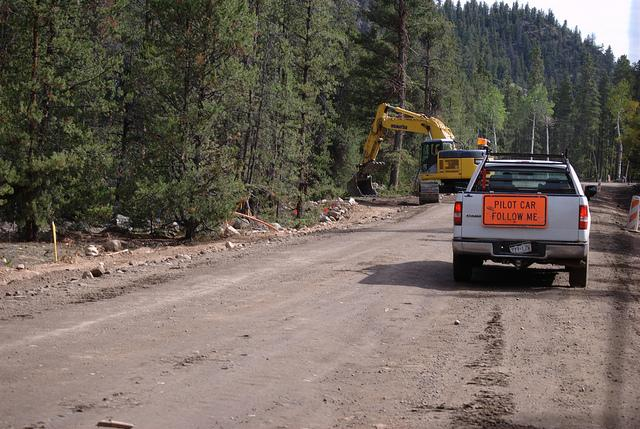What are you instructed to do? follow 